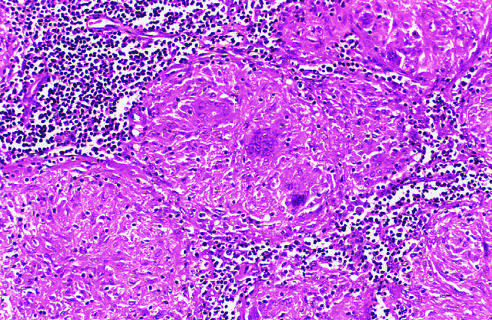does the granuloma in the center show several multinucleate giant cells?
Answer the question using a single word or phrase. Yes 